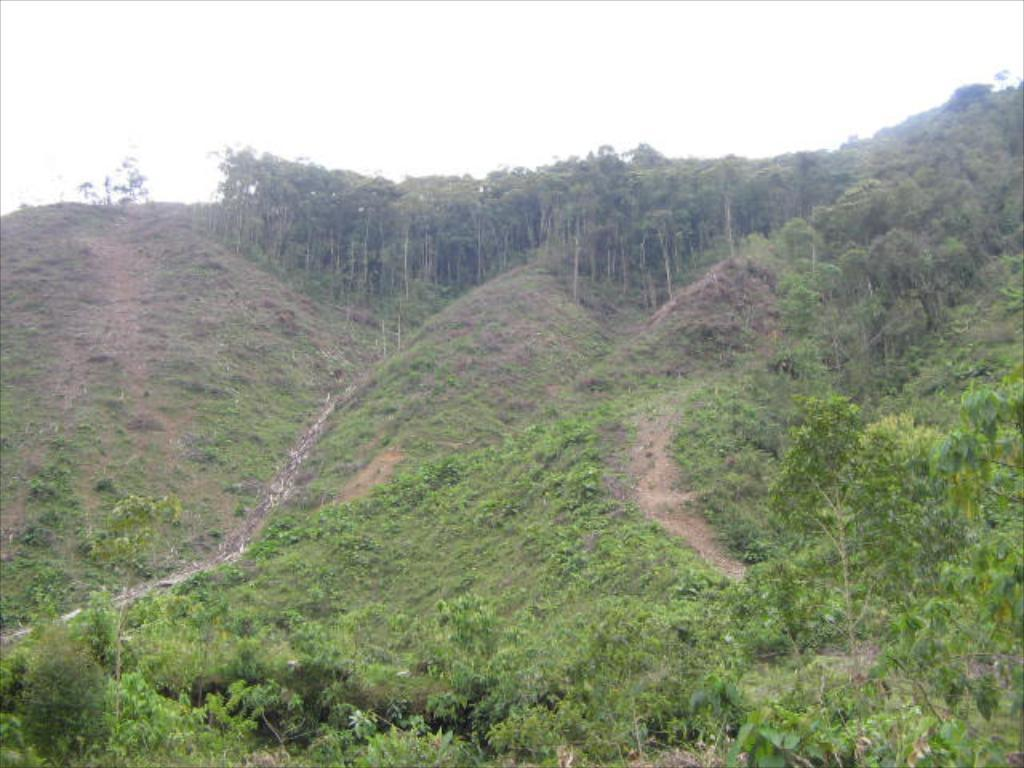What type of vegetation can be seen in the image? There are many trees and grass in the image. Where are the trees and grass located? The trees and grass are located on a hill area. What can be observed about the trees on the top of the hill? There are tall trees on the top of the hill. What type of silk is being used to make the cast for the trees on the hill? There is no cast or silk present in the image; it features trees and grass on a hill. 